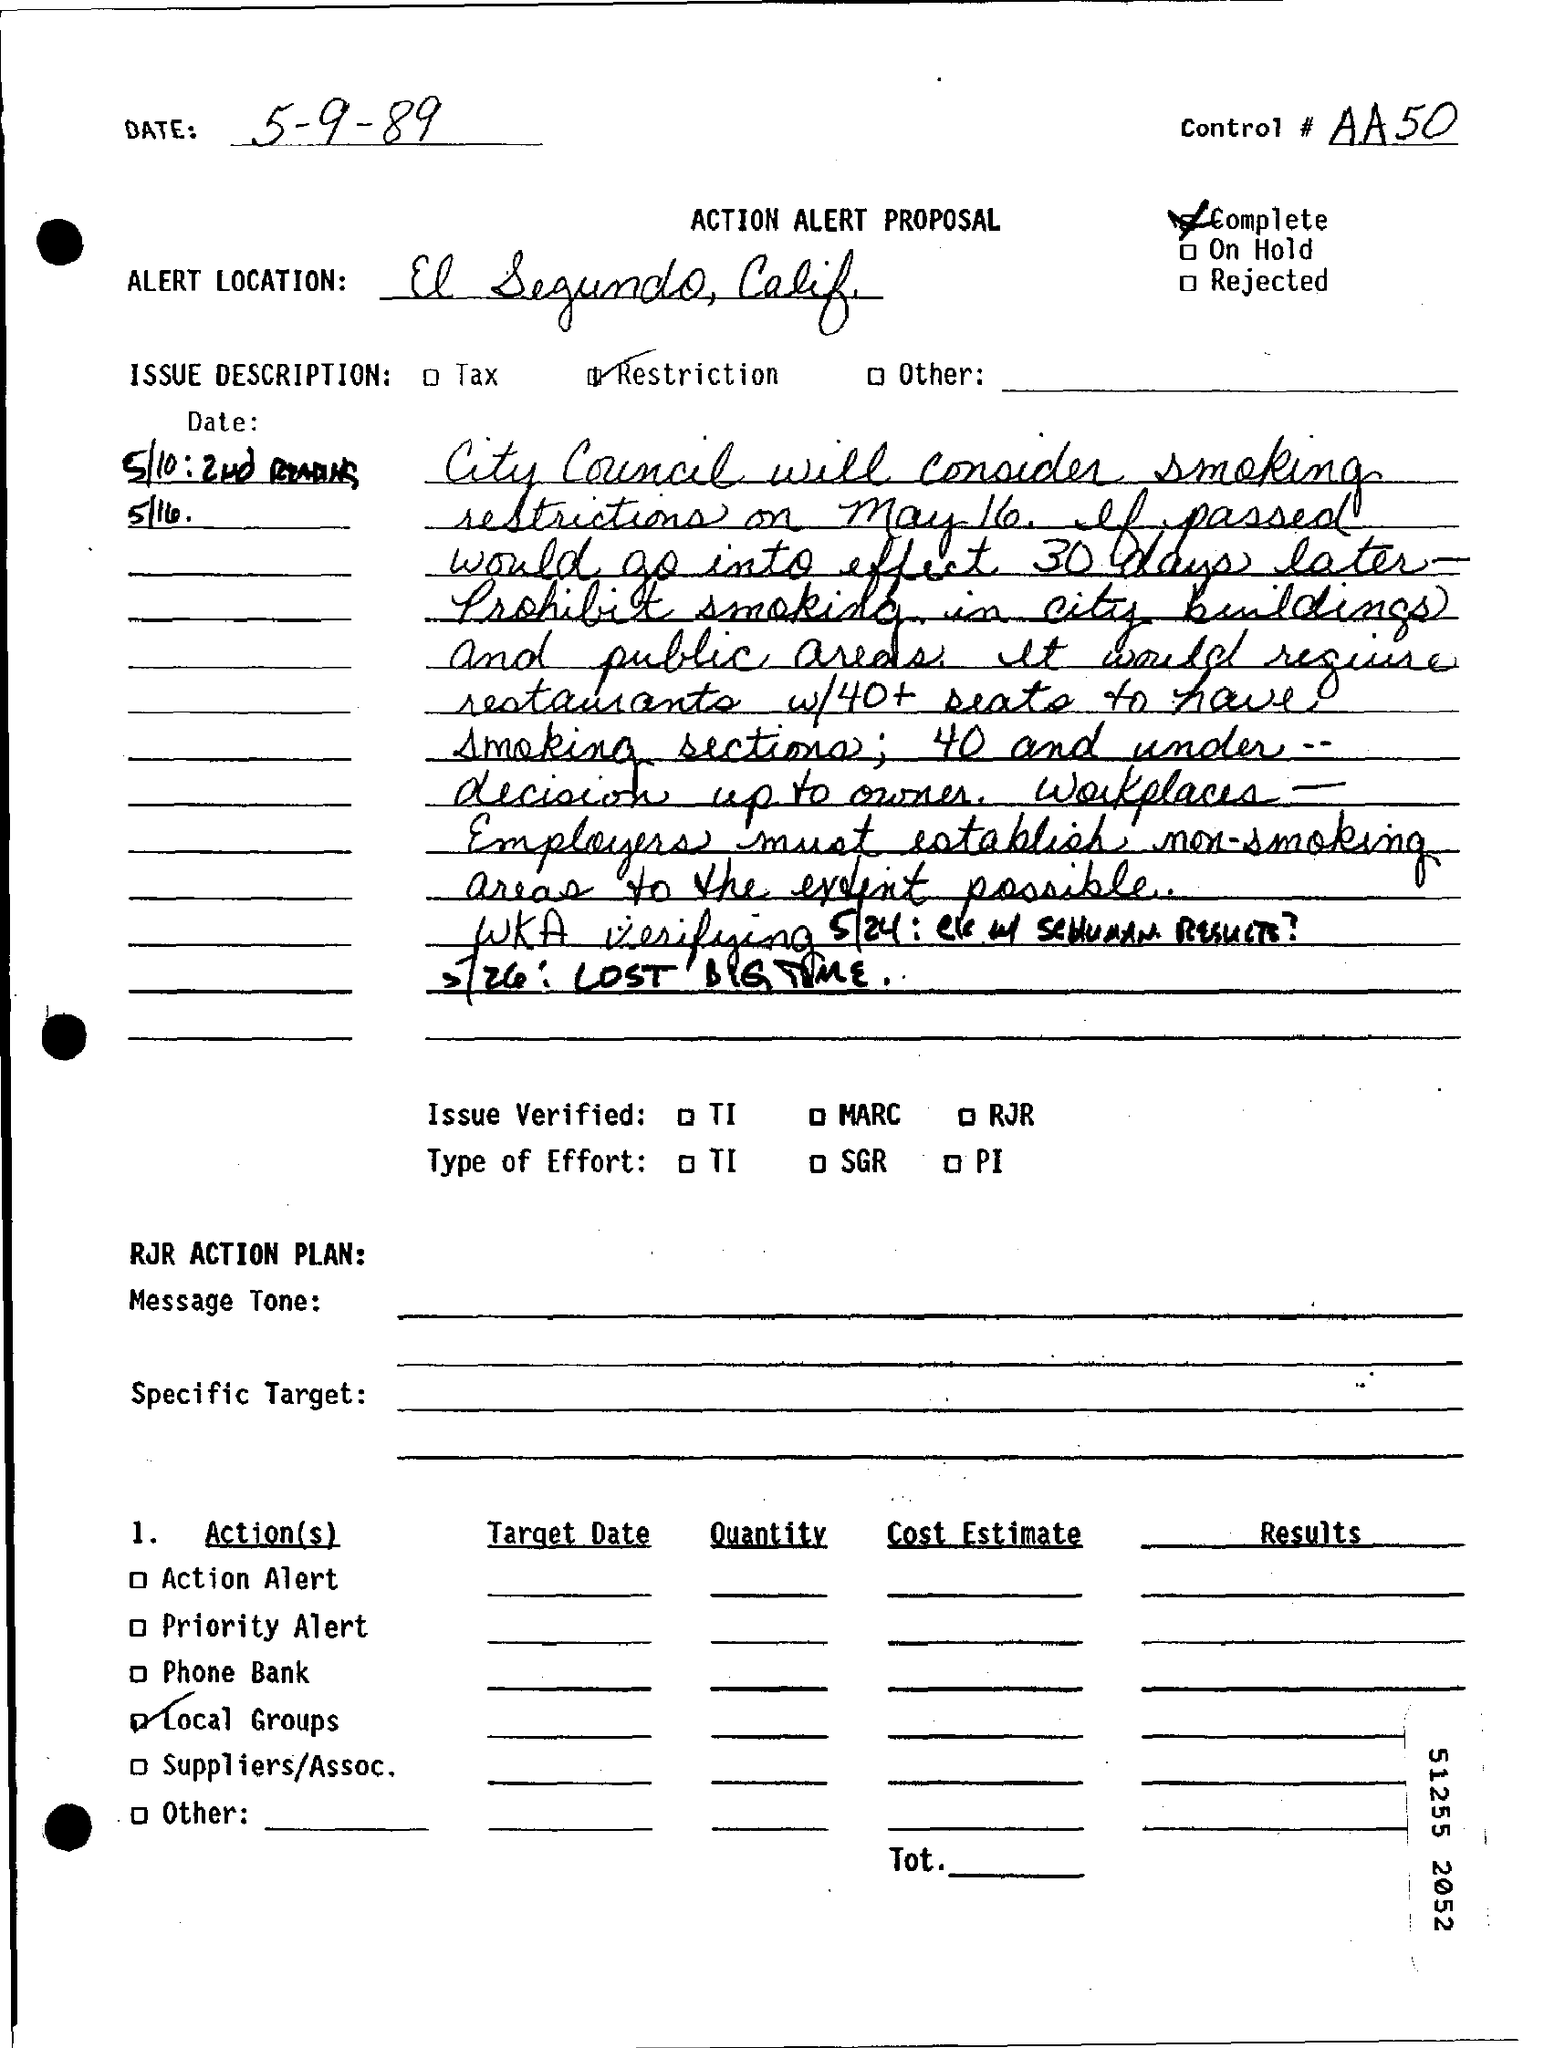Outline some significant characteristics in this image. The date of the document is May 9, 1989. Control# is a programming construct that allows for the creation and management of resources within a program. 